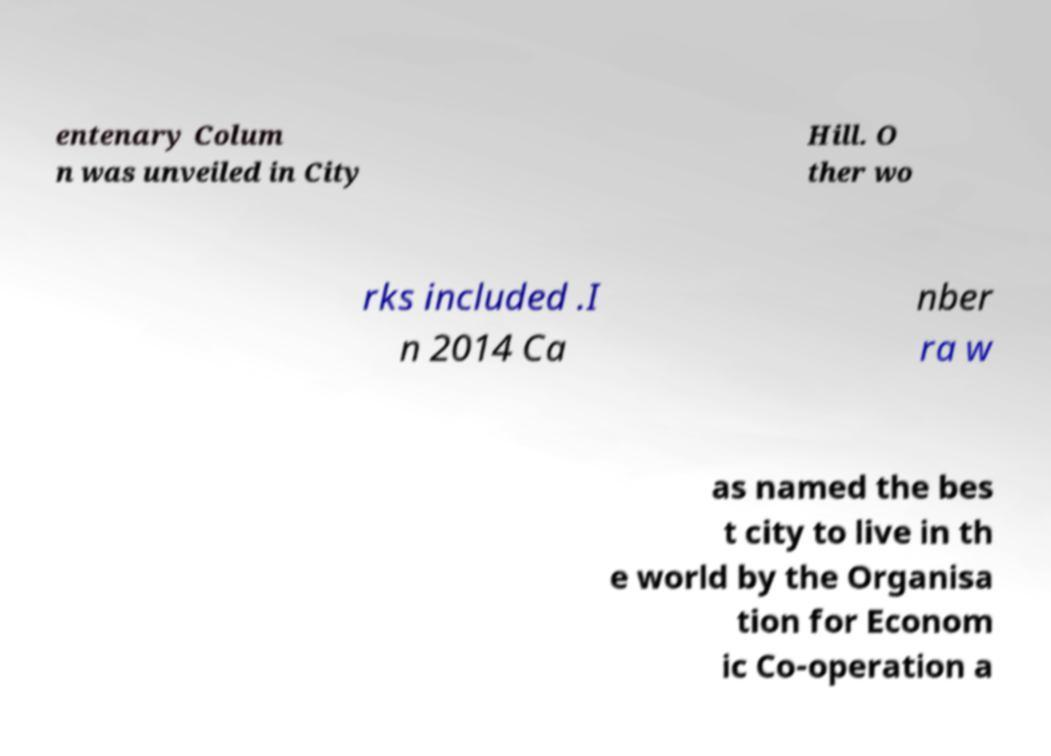Could you extract and type out the text from this image? entenary Colum n was unveiled in City Hill. O ther wo rks included .I n 2014 Ca nber ra w as named the bes t city to live in th e world by the Organisa tion for Econom ic Co-operation a 